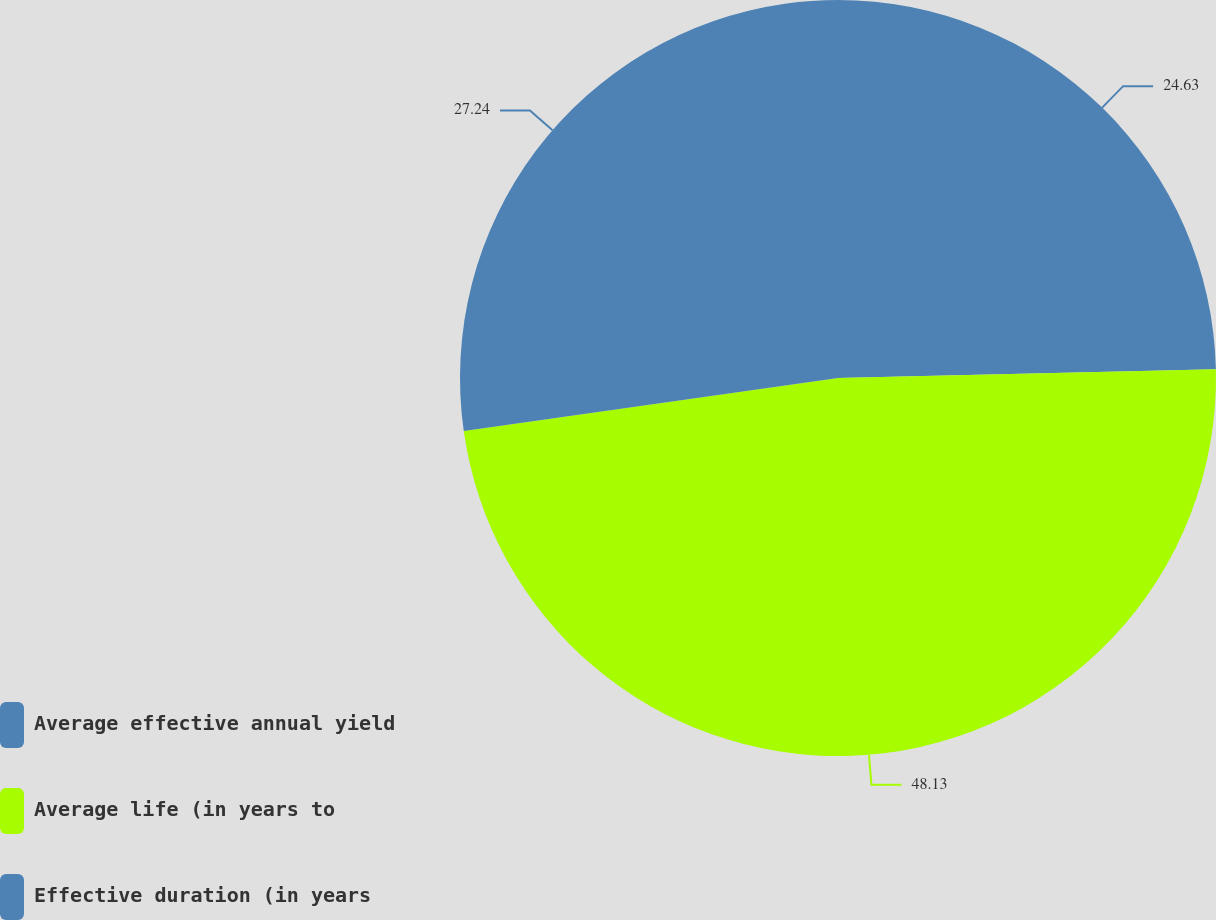Convert chart to OTSL. <chart><loc_0><loc_0><loc_500><loc_500><pie_chart><fcel>Average effective annual yield<fcel>Average life (in years to<fcel>Effective duration (in years<nl><fcel>24.63%<fcel>48.13%<fcel>27.24%<nl></chart> 